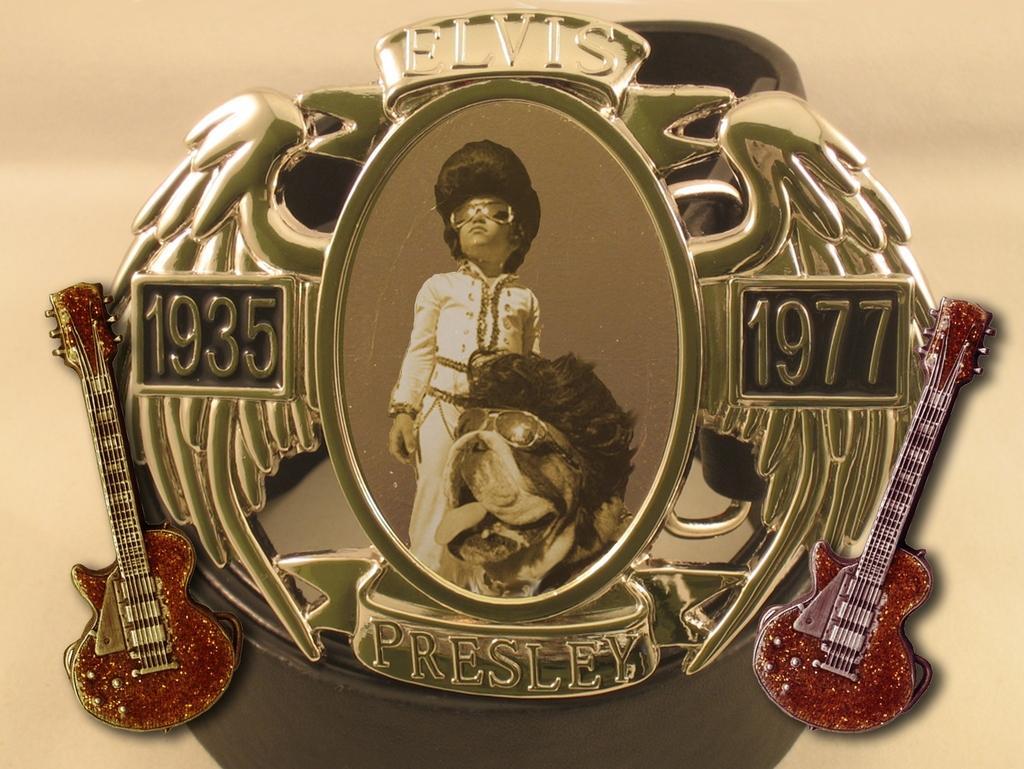Can you describe this image briefly? In this image there is a design photo frame in which there is a photo. There are two guitars on either side of the frame. In the frame there is a boy, beside the boy there is a dog. 